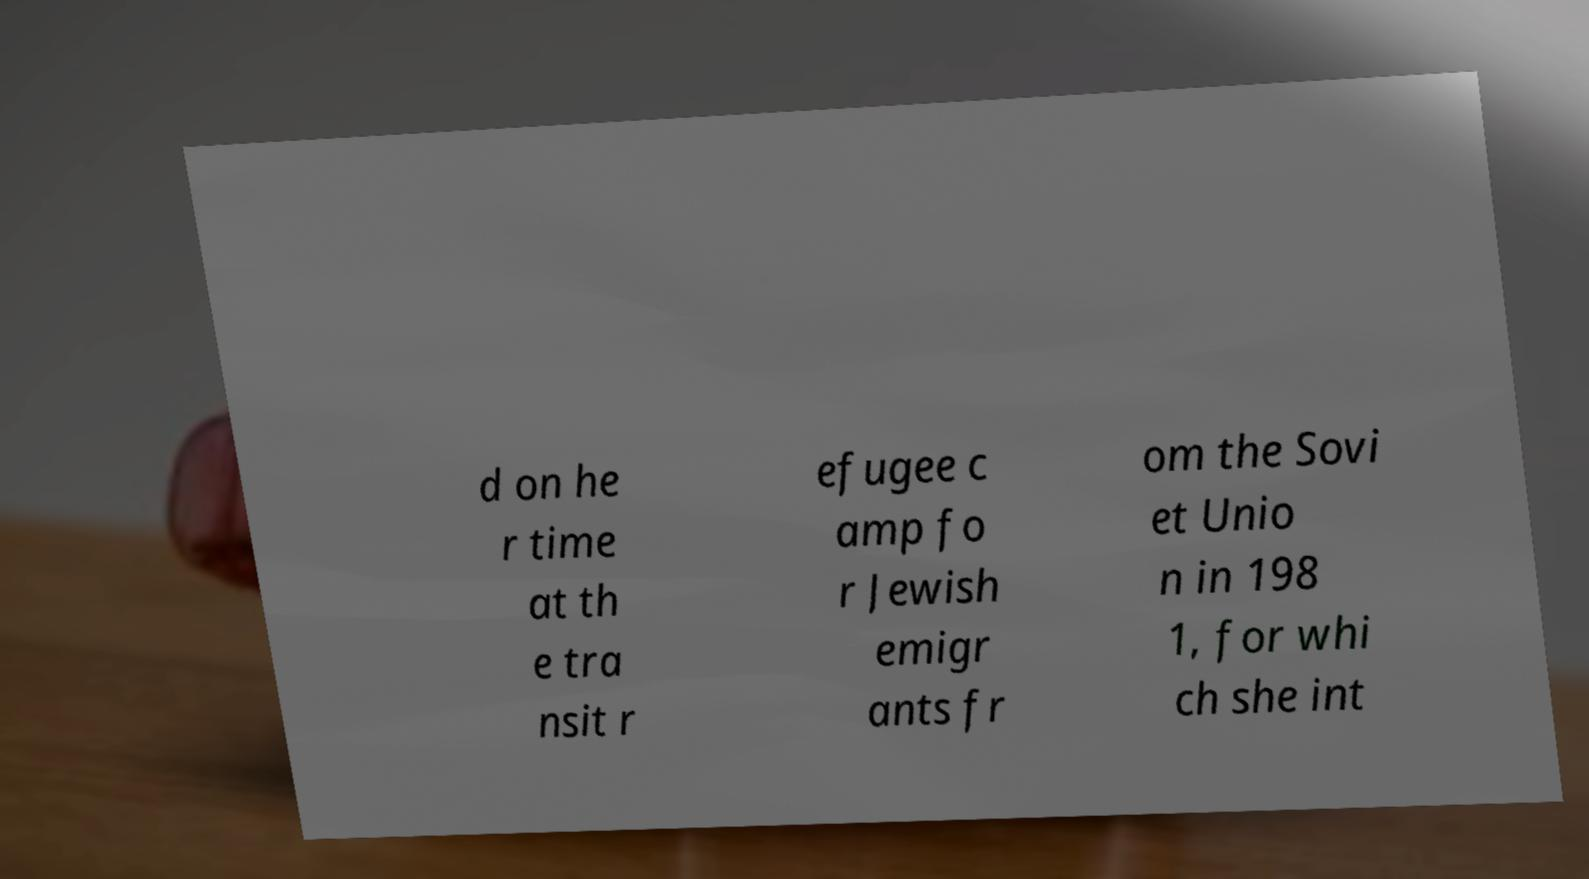Please read and relay the text visible in this image. What does it say? d on he r time at th e tra nsit r efugee c amp fo r Jewish emigr ants fr om the Sovi et Unio n in 198 1, for whi ch she int 